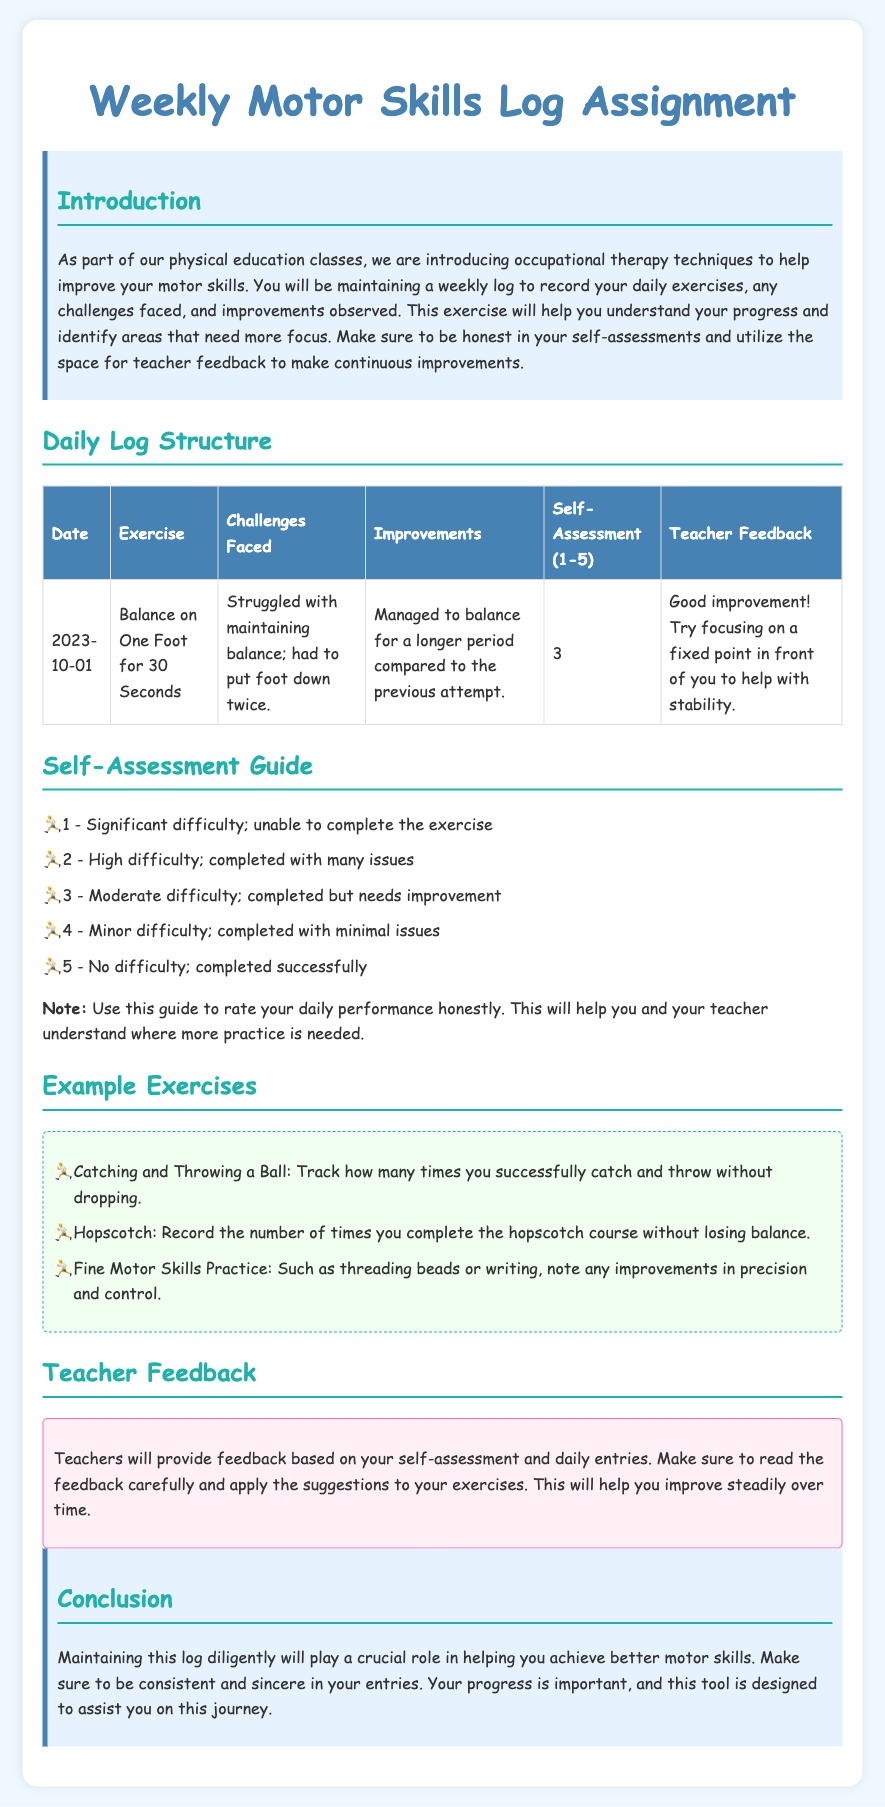What is the title of the assignment? The title is prominently displayed at the top of the document, indicating the nature of the work required.
Answer: Weekly Motor Skills Log Assignment What date is the first entry in the example log? The first date listed in the example table under the Daily Log Structure provides the starting point for tracking.
Answer: 2023-10-01 What self-assessment score did the example entry receive? The self-assessment section in the example log shows how the participant evaluated their performance.
Answer: 3 What exercise is listed for the example log entry? The exercise mentioned in the example log entry is a key part of the tracking process for motor skills development.
Answer: Balance on One Foot for 30 Seconds How many example exercises are provided? Counting the bullet points in the Example Exercises section reveals the number of suggested activities.
Answer: 3 What color is the background of the introduction section? The introduction section's background color contributes to its visual distinction within the document.
Answer: Light blue What range does the self-assessment scale cover? The self-assessment guide specifies the range used for evaluation, indicating how participants can rate their performance.
Answer: 1-5 Which exercise focuses on fine motor skills? The fine motor skills practice mentioned in the example exercises directs attention to specific skill enhancement activities.
Answer: Fine Motor Skills Practice What type of feedback will teachers provide according to the document? The section on teacher feedback outlines the nature of responses participants can expect based on their logs.
Answer: Feedback based on self-assessment and daily entries 